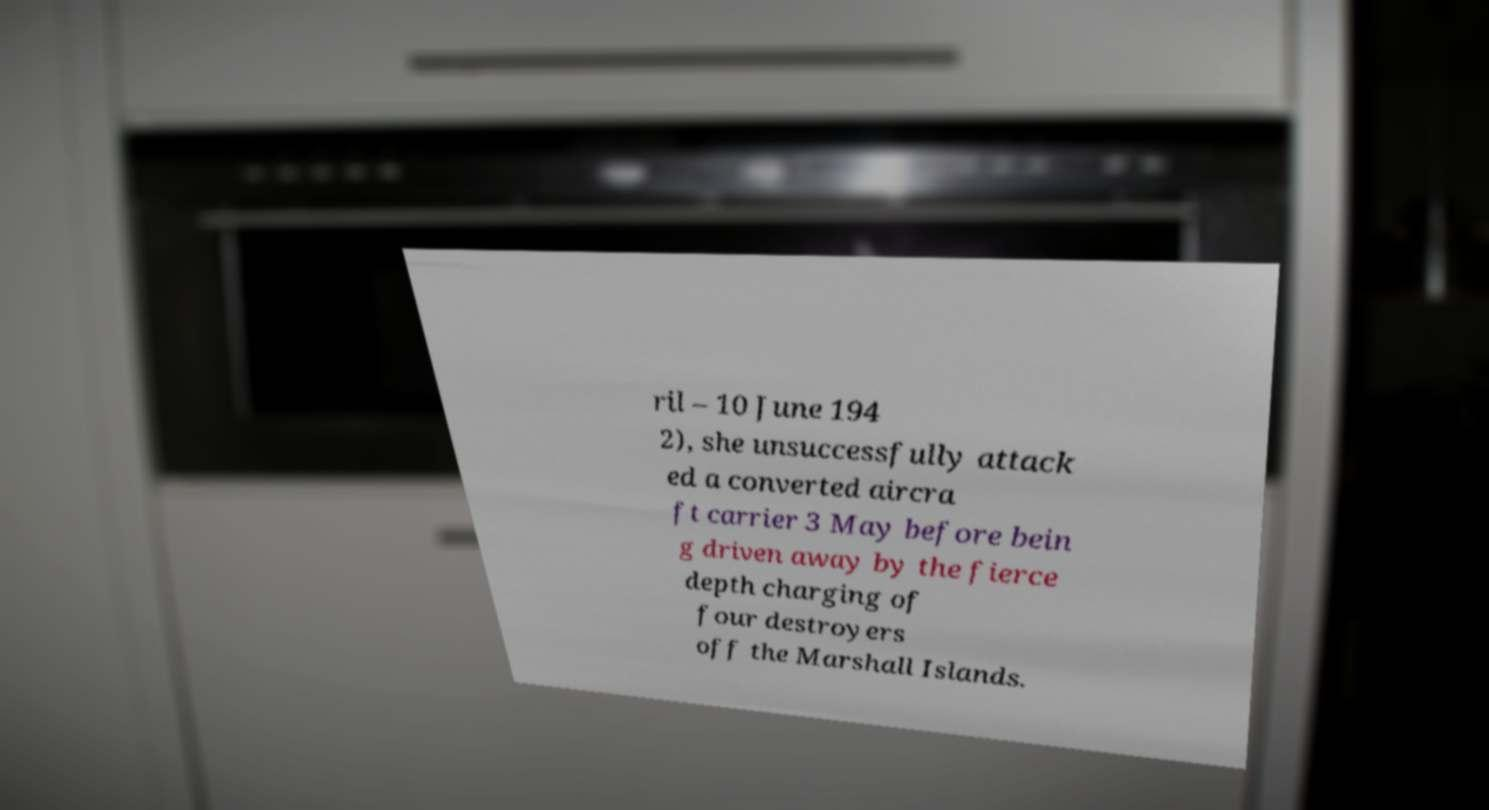Can you read and provide the text displayed in the image?This photo seems to have some interesting text. Can you extract and type it out for me? ril – 10 June 194 2), she unsuccessfully attack ed a converted aircra ft carrier 3 May before bein g driven away by the fierce depth charging of four destroyers off the Marshall Islands. 